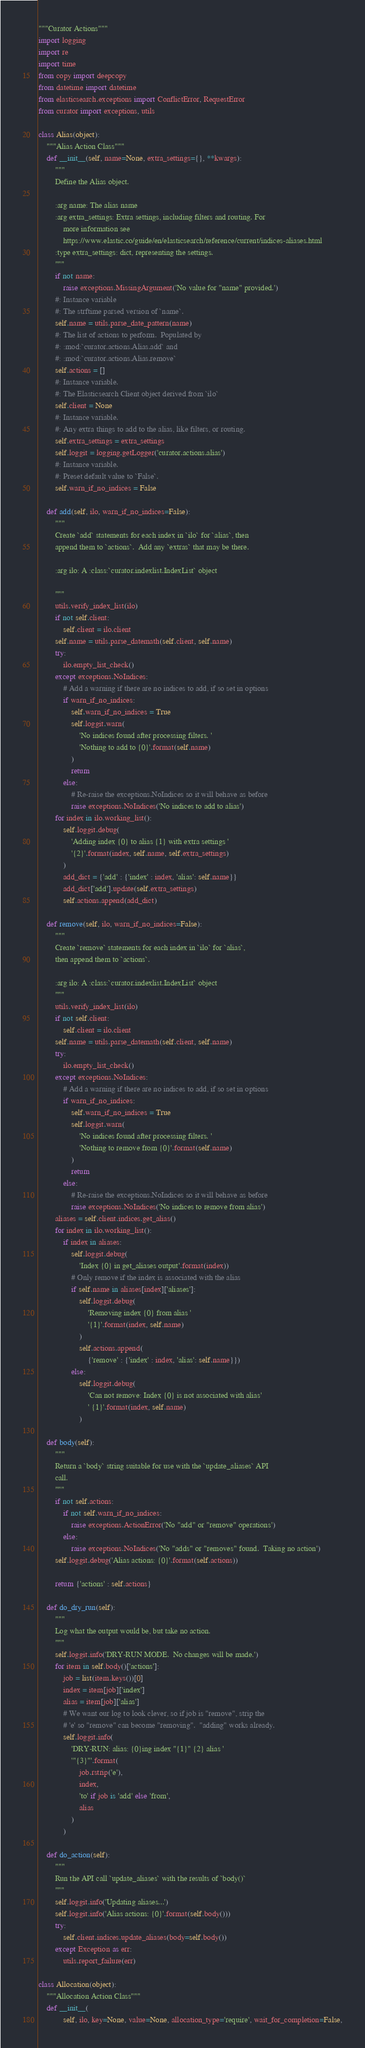Convert code to text. <code><loc_0><loc_0><loc_500><loc_500><_Python_>"""Curator Actions"""
import logging
import re
import time
from copy import deepcopy
from datetime import datetime
from elasticsearch.exceptions import ConflictError, RequestError
from curator import exceptions, utils

class Alias(object):
    """Alias Action Class"""
    def __init__(self, name=None, extra_settings={}, **kwargs):
        """
        Define the Alias object.

        :arg name: The alias name
        :arg extra_settings: Extra settings, including filters and routing. For
            more information see
            https://www.elastic.co/guide/en/elasticsearch/reference/current/indices-aliases.html
        :type extra_settings: dict, representing the settings.
        """
        if not name:
            raise exceptions.MissingArgument('No value for "name" provided.')
        #: Instance variable
        #: The strftime parsed version of `name`.
        self.name = utils.parse_date_pattern(name)
        #: The list of actions to perform.  Populated by
        #: :mod:`curator.actions.Alias.add` and
        #: :mod:`curator.actions.Alias.remove`
        self.actions = []
        #: Instance variable.
        #: The Elasticsearch Client object derived from `ilo`
        self.client = None
        #: Instance variable.
        #: Any extra things to add to the alias, like filters, or routing.
        self.extra_settings = extra_settings
        self.loggit = logging.getLogger('curator.actions.alias')
        #: Instance variable.
        #: Preset default value to `False`.
        self.warn_if_no_indices = False

    def add(self, ilo, warn_if_no_indices=False):
        """
        Create `add` statements for each index in `ilo` for `alias`, then
        append them to `actions`.  Add any `extras` that may be there.

        :arg ilo: A :class:`curator.indexlist.IndexList` object

        """
        utils.verify_index_list(ilo)
        if not self.client:
            self.client = ilo.client
        self.name = utils.parse_datemath(self.client, self.name)
        try:
            ilo.empty_list_check()
        except exceptions.NoIndices:
            # Add a warning if there are no indices to add, if so set in options
            if warn_if_no_indices:
                self.warn_if_no_indices = True
                self.loggit.warn(
                    'No indices found after processing filters. '
                    'Nothing to add to {0}'.format(self.name)
                )
                return
            else:
                # Re-raise the exceptions.NoIndices so it will behave as before
                raise exceptions.NoIndices('No indices to add to alias')
        for index in ilo.working_list():
            self.loggit.debug(
                'Adding index {0} to alias {1} with extra settings '
                '{2}'.format(index, self.name, self.extra_settings)
            )
            add_dict = {'add' : {'index' : index, 'alias': self.name}}
            add_dict['add'].update(self.extra_settings)
            self.actions.append(add_dict)

    def remove(self, ilo, warn_if_no_indices=False):
        """
        Create `remove` statements for each index in `ilo` for `alias`,
        then append them to `actions`.

        :arg ilo: A :class:`curator.indexlist.IndexList` object
        """
        utils.verify_index_list(ilo)
        if not self.client:
            self.client = ilo.client
        self.name = utils.parse_datemath(self.client, self.name)
        try:
            ilo.empty_list_check()
        except exceptions.NoIndices:
            # Add a warning if there are no indices to add, if so set in options
            if warn_if_no_indices:
                self.warn_if_no_indices = True
                self.loggit.warn(
                    'No indices found after processing filters. '
                    'Nothing to remove from {0}'.format(self.name)
                )
                return
            else:
                # Re-raise the exceptions.NoIndices so it will behave as before
                raise exceptions.NoIndices('No indices to remove from alias')
        aliases = self.client.indices.get_alias()
        for index in ilo.working_list():
            if index in aliases:
                self.loggit.debug(
                    'Index {0} in get_aliases output'.format(index))
                # Only remove if the index is associated with the alias
                if self.name in aliases[index]['aliases']:
                    self.loggit.debug(
                        'Removing index {0} from alias '
                        '{1}'.format(index, self.name)
                    )
                    self.actions.append(
                        {'remove' : {'index' : index, 'alias': self.name}})
                else:
                    self.loggit.debug(
                        'Can not remove: Index {0} is not associated with alias'
                        ' {1}'.format(index, self.name)
                    )

    def body(self):
        """
        Return a `body` string suitable for use with the `update_aliases` API
        call.
        """
        if not self.actions:
            if not self.warn_if_no_indices:
                raise exceptions.ActionError('No "add" or "remove" operations')
            else:
                raise exceptions.NoIndices('No "adds" or "removes" found.  Taking no action')
        self.loggit.debug('Alias actions: {0}'.format(self.actions))

        return {'actions' : self.actions}

    def do_dry_run(self):
        """
        Log what the output would be, but take no action.
        """
        self.loggit.info('DRY-RUN MODE.  No changes will be made.')
        for item in self.body()['actions']:
            job = list(item.keys())[0]
            index = item[job]['index']
            alias = item[job]['alias']
            # We want our log to look clever, so if job is "remove", strip the
            # 'e' so "remove" can become "removing".  "adding" works already.
            self.loggit.info(
                'DRY-RUN: alias: {0}ing index "{1}" {2} alias '
                '"{3}"'.format(
                    job.rstrip('e'),
                    index,
                    'to' if job is 'add' else 'from',
                    alias
                )
            )

    def do_action(self):
        """
        Run the API call `update_aliases` with the results of `body()`
        """
        self.loggit.info('Updating aliases...')
        self.loggit.info('Alias actions: {0}'.format(self.body()))
        try:
            self.client.indices.update_aliases(body=self.body())
        except Exception as err:
            utils.report_failure(err)

class Allocation(object):
    """Allocation Action Class"""
    def __init__(
            self, ilo, key=None, value=None, allocation_type='require', wait_for_completion=False,</code> 